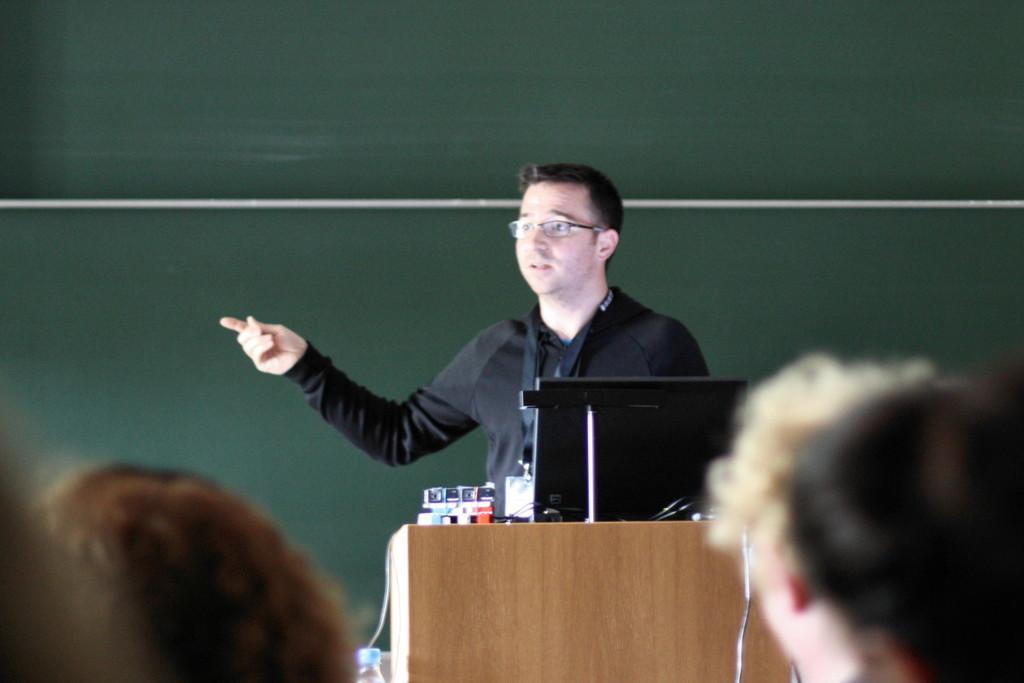How would you summarize this image in a sentence or two? In this image there is a man standing in front of the podium and talking. There is a laptop on the podium. There is crowd in front of him. At the background there is a wall. 